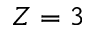<formula> <loc_0><loc_0><loc_500><loc_500>Z = 3</formula> 